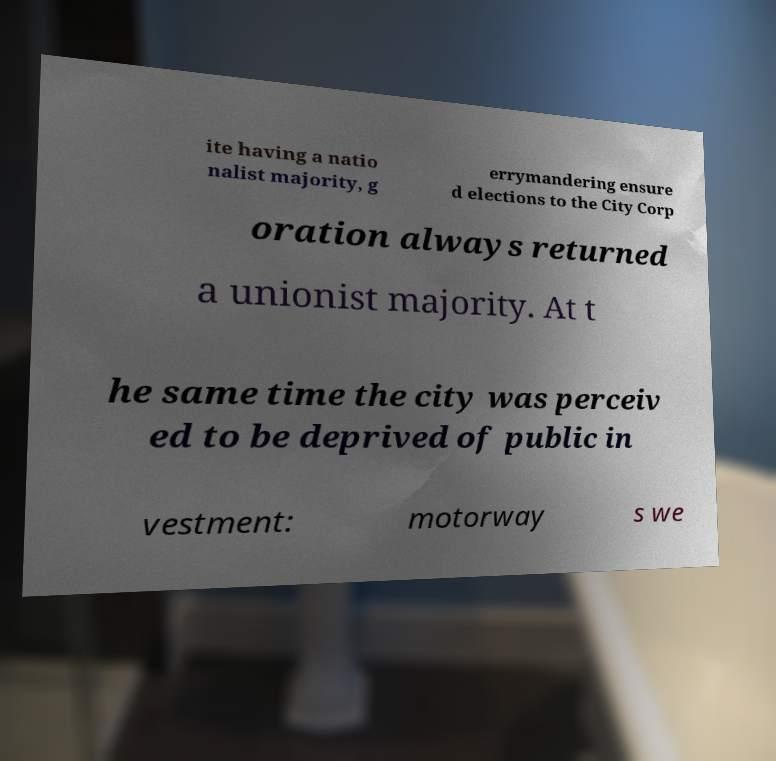What messages or text are displayed in this image? I need them in a readable, typed format. ite having a natio nalist majority, g errymandering ensure d elections to the City Corp oration always returned a unionist majority. At t he same time the city was perceiv ed to be deprived of public in vestment: motorway s we 